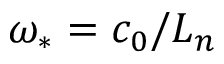Convert formula to latex. <formula><loc_0><loc_0><loc_500><loc_500>\omega _ { \ast } = c _ { 0 } / L _ { n }</formula> 